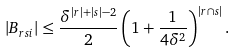Convert formula to latex. <formula><loc_0><loc_0><loc_500><loc_500>| B _ { r s i } | \leq \frac { \delta ^ { | r | + | s | - 2 } } { 2 } \left ( 1 + \frac { 1 } { 4 \delta ^ { 2 } } \right ) ^ { | r \cap s | } .</formula> 